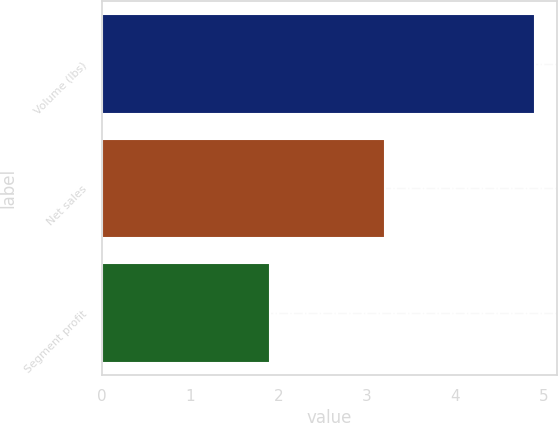Convert chart. <chart><loc_0><loc_0><loc_500><loc_500><bar_chart><fcel>Volume (lbs)<fcel>Net sales<fcel>Segment profit<nl><fcel>4.9<fcel>3.2<fcel>1.9<nl></chart> 